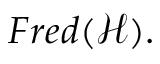<formula> <loc_0><loc_0><loc_500><loc_500>F r e d ( { \mathcal { H } } ) .</formula> 